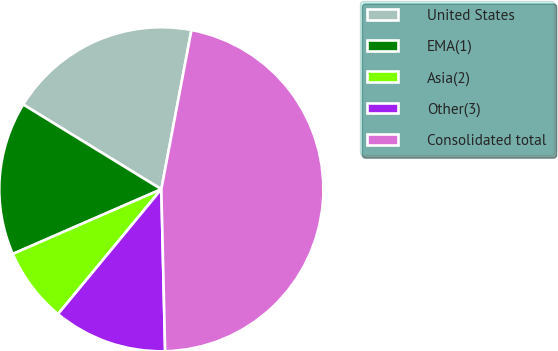Convert chart. <chart><loc_0><loc_0><loc_500><loc_500><pie_chart><fcel>United States<fcel>EMA(1)<fcel>Asia(2)<fcel>Other(3)<fcel>Consolidated total<nl><fcel>19.22%<fcel>15.3%<fcel>7.46%<fcel>11.38%<fcel>46.65%<nl></chart> 